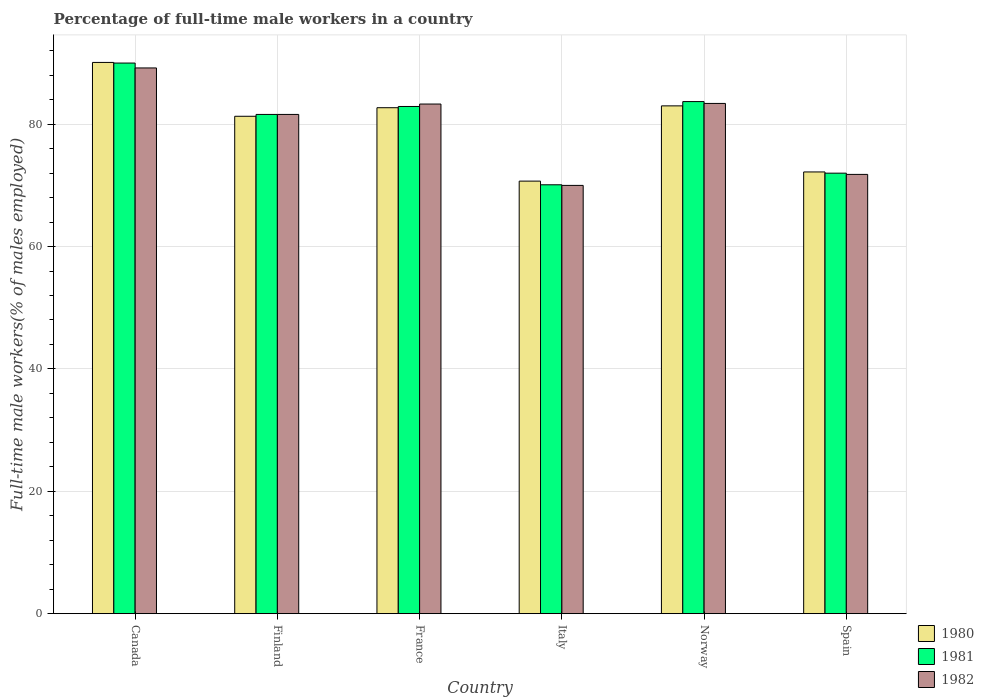How many different coloured bars are there?
Provide a short and direct response. 3. How many bars are there on the 5th tick from the left?
Offer a terse response. 3. What is the label of the 5th group of bars from the left?
Keep it short and to the point. Norway. In how many cases, is the number of bars for a given country not equal to the number of legend labels?
Provide a short and direct response. 0. What is the percentage of full-time male workers in 1981 in Norway?
Keep it short and to the point. 83.7. What is the total percentage of full-time male workers in 1980 in the graph?
Your answer should be very brief. 480. What is the difference between the percentage of full-time male workers in 1980 in Finland and that in Spain?
Offer a very short reply. 9.1. What is the average percentage of full-time male workers in 1982 per country?
Provide a short and direct response. 79.88. What is the difference between the percentage of full-time male workers of/in 1980 and percentage of full-time male workers of/in 1981 in Finland?
Your response must be concise. -0.3. What is the ratio of the percentage of full-time male workers in 1980 in France to that in Spain?
Your response must be concise. 1.15. Is the percentage of full-time male workers in 1980 in Canada less than that in Finland?
Provide a succinct answer. No. What is the difference between the highest and the second highest percentage of full-time male workers in 1981?
Offer a terse response. 6.3. What is the difference between the highest and the lowest percentage of full-time male workers in 1980?
Your response must be concise. 19.4. In how many countries, is the percentage of full-time male workers in 1980 greater than the average percentage of full-time male workers in 1980 taken over all countries?
Provide a succinct answer. 4. Is the sum of the percentage of full-time male workers in 1981 in France and Italy greater than the maximum percentage of full-time male workers in 1982 across all countries?
Offer a very short reply. Yes. What does the 2nd bar from the right in Canada represents?
Keep it short and to the point. 1981. How many bars are there?
Ensure brevity in your answer.  18. Does the graph contain any zero values?
Your answer should be very brief. No. Does the graph contain grids?
Make the answer very short. Yes. How are the legend labels stacked?
Your response must be concise. Vertical. What is the title of the graph?
Keep it short and to the point. Percentage of full-time male workers in a country. Does "1997" appear as one of the legend labels in the graph?
Offer a terse response. No. What is the label or title of the Y-axis?
Give a very brief answer. Full-time male workers(% of males employed). What is the Full-time male workers(% of males employed) of 1980 in Canada?
Your response must be concise. 90.1. What is the Full-time male workers(% of males employed) in 1981 in Canada?
Your response must be concise. 90. What is the Full-time male workers(% of males employed) in 1982 in Canada?
Ensure brevity in your answer.  89.2. What is the Full-time male workers(% of males employed) of 1980 in Finland?
Your response must be concise. 81.3. What is the Full-time male workers(% of males employed) of 1981 in Finland?
Keep it short and to the point. 81.6. What is the Full-time male workers(% of males employed) in 1982 in Finland?
Your answer should be very brief. 81.6. What is the Full-time male workers(% of males employed) of 1980 in France?
Give a very brief answer. 82.7. What is the Full-time male workers(% of males employed) of 1981 in France?
Your answer should be compact. 82.9. What is the Full-time male workers(% of males employed) in 1982 in France?
Keep it short and to the point. 83.3. What is the Full-time male workers(% of males employed) of 1980 in Italy?
Provide a succinct answer. 70.7. What is the Full-time male workers(% of males employed) in 1981 in Italy?
Make the answer very short. 70.1. What is the Full-time male workers(% of males employed) of 1982 in Italy?
Your answer should be very brief. 70. What is the Full-time male workers(% of males employed) of 1981 in Norway?
Your response must be concise. 83.7. What is the Full-time male workers(% of males employed) of 1982 in Norway?
Your answer should be compact. 83.4. What is the Full-time male workers(% of males employed) in 1980 in Spain?
Keep it short and to the point. 72.2. What is the Full-time male workers(% of males employed) in 1981 in Spain?
Offer a very short reply. 72. What is the Full-time male workers(% of males employed) in 1982 in Spain?
Offer a terse response. 71.8. Across all countries, what is the maximum Full-time male workers(% of males employed) in 1980?
Offer a very short reply. 90.1. Across all countries, what is the maximum Full-time male workers(% of males employed) of 1981?
Your response must be concise. 90. Across all countries, what is the maximum Full-time male workers(% of males employed) of 1982?
Your response must be concise. 89.2. Across all countries, what is the minimum Full-time male workers(% of males employed) of 1980?
Keep it short and to the point. 70.7. Across all countries, what is the minimum Full-time male workers(% of males employed) of 1981?
Offer a terse response. 70.1. Across all countries, what is the minimum Full-time male workers(% of males employed) in 1982?
Offer a terse response. 70. What is the total Full-time male workers(% of males employed) in 1980 in the graph?
Keep it short and to the point. 480. What is the total Full-time male workers(% of males employed) in 1981 in the graph?
Provide a succinct answer. 480.3. What is the total Full-time male workers(% of males employed) in 1982 in the graph?
Ensure brevity in your answer.  479.3. What is the difference between the Full-time male workers(% of males employed) of 1981 in Canada and that in Finland?
Provide a short and direct response. 8.4. What is the difference between the Full-time male workers(% of males employed) of 1980 in Canada and that in Italy?
Offer a very short reply. 19.4. What is the difference between the Full-time male workers(% of males employed) of 1981 in Canada and that in Norway?
Provide a short and direct response. 6.3. What is the difference between the Full-time male workers(% of males employed) of 1982 in Canada and that in Norway?
Provide a succinct answer. 5.8. What is the difference between the Full-time male workers(% of males employed) in 1980 in Canada and that in Spain?
Keep it short and to the point. 17.9. What is the difference between the Full-time male workers(% of males employed) of 1982 in Canada and that in Spain?
Provide a succinct answer. 17.4. What is the difference between the Full-time male workers(% of males employed) of 1980 in Finland and that in France?
Offer a terse response. -1.4. What is the difference between the Full-time male workers(% of males employed) in 1982 in Finland and that in France?
Make the answer very short. -1.7. What is the difference between the Full-time male workers(% of males employed) in 1982 in Finland and that in Italy?
Your answer should be compact. 11.6. What is the difference between the Full-time male workers(% of males employed) of 1982 in Finland and that in Norway?
Give a very brief answer. -1.8. What is the difference between the Full-time male workers(% of males employed) in 1981 in Finland and that in Spain?
Your response must be concise. 9.6. What is the difference between the Full-time male workers(% of males employed) of 1982 in Finland and that in Spain?
Offer a very short reply. 9.8. What is the difference between the Full-time male workers(% of males employed) in 1980 in France and that in Italy?
Give a very brief answer. 12. What is the difference between the Full-time male workers(% of males employed) in 1981 in France and that in Norway?
Make the answer very short. -0.8. What is the difference between the Full-time male workers(% of males employed) of 1980 in Italy and that in Norway?
Provide a short and direct response. -12.3. What is the difference between the Full-time male workers(% of males employed) in 1980 in Italy and that in Spain?
Offer a terse response. -1.5. What is the difference between the Full-time male workers(% of males employed) in 1982 in Italy and that in Spain?
Your answer should be very brief. -1.8. What is the difference between the Full-time male workers(% of males employed) of 1981 in Norway and that in Spain?
Provide a succinct answer. 11.7. What is the difference between the Full-time male workers(% of males employed) in 1982 in Norway and that in Spain?
Your answer should be very brief. 11.6. What is the difference between the Full-time male workers(% of males employed) of 1980 in Canada and the Full-time male workers(% of males employed) of 1982 in Finland?
Give a very brief answer. 8.5. What is the difference between the Full-time male workers(% of males employed) in 1981 in Canada and the Full-time male workers(% of males employed) in 1982 in Finland?
Ensure brevity in your answer.  8.4. What is the difference between the Full-time male workers(% of males employed) in 1980 in Canada and the Full-time male workers(% of males employed) in 1982 in France?
Your answer should be compact. 6.8. What is the difference between the Full-time male workers(% of males employed) in 1980 in Canada and the Full-time male workers(% of males employed) in 1982 in Italy?
Offer a terse response. 20.1. What is the difference between the Full-time male workers(% of males employed) in 1980 in Canada and the Full-time male workers(% of males employed) in 1981 in Spain?
Ensure brevity in your answer.  18.1. What is the difference between the Full-time male workers(% of males employed) in 1980 in Finland and the Full-time male workers(% of males employed) in 1982 in France?
Make the answer very short. -2. What is the difference between the Full-time male workers(% of males employed) of 1980 in Finland and the Full-time male workers(% of males employed) of 1981 in Italy?
Your answer should be very brief. 11.2. What is the difference between the Full-time male workers(% of males employed) in 1980 in Finland and the Full-time male workers(% of males employed) in 1981 in Norway?
Give a very brief answer. -2.4. What is the difference between the Full-time male workers(% of males employed) in 1980 in Finland and the Full-time male workers(% of males employed) in 1982 in Norway?
Your response must be concise. -2.1. What is the difference between the Full-time male workers(% of males employed) of 1981 in Finland and the Full-time male workers(% of males employed) of 1982 in Norway?
Provide a short and direct response. -1.8. What is the difference between the Full-time male workers(% of males employed) of 1980 in Finland and the Full-time male workers(% of males employed) of 1981 in Spain?
Give a very brief answer. 9.3. What is the difference between the Full-time male workers(% of males employed) in 1980 in Finland and the Full-time male workers(% of males employed) in 1982 in Spain?
Give a very brief answer. 9.5. What is the difference between the Full-time male workers(% of males employed) of 1981 in Finland and the Full-time male workers(% of males employed) of 1982 in Spain?
Your answer should be very brief. 9.8. What is the difference between the Full-time male workers(% of males employed) in 1980 in France and the Full-time male workers(% of males employed) in 1981 in Italy?
Your answer should be compact. 12.6. What is the difference between the Full-time male workers(% of males employed) in 1981 in France and the Full-time male workers(% of males employed) in 1982 in Italy?
Provide a succinct answer. 12.9. What is the difference between the Full-time male workers(% of males employed) in 1981 in France and the Full-time male workers(% of males employed) in 1982 in Norway?
Provide a short and direct response. -0.5. What is the difference between the Full-time male workers(% of males employed) in 1980 in France and the Full-time male workers(% of males employed) in 1981 in Spain?
Keep it short and to the point. 10.7. What is the difference between the Full-time male workers(% of males employed) in 1980 in France and the Full-time male workers(% of males employed) in 1982 in Spain?
Your answer should be compact. 10.9. What is the difference between the Full-time male workers(% of males employed) in 1981 in France and the Full-time male workers(% of males employed) in 1982 in Spain?
Make the answer very short. 11.1. What is the difference between the Full-time male workers(% of males employed) in 1980 in Italy and the Full-time male workers(% of males employed) in 1982 in Norway?
Give a very brief answer. -12.7. What is the difference between the Full-time male workers(% of males employed) of 1980 in Italy and the Full-time male workers(% of males employed) of 1982 in Spain?
Give a very brief answer. -1.1. What is the difference between the Full-time male workers(% of males employed) in 1980 in Norway and the Full-time male workers(% of males employed) in 1982 in Spain?
Offer a very short reply. 11.2. What is the average Full-time male workers(% of males employed) in 1980 per country?
Ensure brevity in your answer.  80. What is the average Full-time male workers(% of males employed) in 1981 per country?
Offer a very short reply. 80.05. What is the average Full-time male workers(% of males employed) in 1982 per country?
Keep it short and to the point. 79.88. What is the difference between the Full-time male workers(% of males employed) in 1980 and Full-time male workers(% of males employed) in 1981 in Canada?
Give a very brief answer. 0.1. What is the difference between the Full-time male workers(% of males employed) of 1980 and Full-time male workers(% of males employed) of 1982 in Canada?
Offer a very short reply. 0.9. What is the difference between the Full-time male workers(% of males employed) in 1980 and Full-time male workers(% of males employed) in 1981 in Finland?
Provide a short and direct response. -0.3. What is the difference between the Full-time male workers(% of males employed) in 1980 and Full-time male workers(% of males employed) in 1982 in Finland?
Offer a terse response. -0.3. What is the difference between the Full-time male workers(% of males employed) in 1981 and Full-time male workers(% of males employed) in 1982 in France?
Keep it short and to the point. -0.4. What is the difference between the Full-time male workers(% of males employed) of 1980 and Full-time male workers(% of males employed) of 1982 in Italy?
Your response must be concise. 0.7. What is the difference between the Full-time male workers(% of males employed) in 1981 and Full-time male workers(% of males employed) in 1982 in Italy?
Provide a short and direct response. 0.1. What is the difference between the Full-time male workers(% of males employed) in 1980 and Full-time male workers(% of males employed) in 1981 in Norway?
Provide a short and direct response. -0.7. What is the ratio of the Full-time male workers(% of males employed) of 1980 in Canada to that in Finland?
Keep it short and to the point. 1.11. What is the ratio of the Full-time male workers(% of males employed) of 1981 in Canada to that in Finland?
Ensure brevity in your answer.  1.1. What is the ratio of the Full-time male workers(% of males employed) in 1982 in Canada to that in Finland?
Ensure brevity in your answer.  1.09. What is the ratio of the Full-time male workers(% of males employed) of 1980 in Canada to that in France?
Give a very brief answer. 1.09. What is the ratio of the Full-time male workers(% of males employed) in 1981 in Canada to that in France?
Keep it short and to the point. 1.09. What is the ratio of the Full-time male workers(% of males employed) of 1982 in Canada to that in France?
Keep it short and to the point. 1.07. What is the ratio of the Full-time male workers(% of males employed) of 1980 in Canada to that in Italy?
Ensure brevity in your answer.  1.27. What is the ratio of the Full-time male workers(% of males employed) of 1981 in Canada to that in Italy?
Make the answer very short. 1.28. What is the ratio of the Full-time male workers(% of males employed) of 1982 in Canada to that in Italy?
Your response must be concise. 1.27. What is the ratio of the Full-time male workers(% of males employed) of 1980 in Canada to that in Norway?
Make the answer very short. 1.09. What is the ratio of the Full-time male workers(% of males employed) of 1981 in Canada to that in Norway?
Keep it short and to the point. 1.08. What is the ratio of the Full-time male workers(% of males employed) in 1982 in Canada to that in Norway?
Your answer should be compact. 1.07. What is the ratio of the Full-time male workers(% of males employed) of 1980 in Canada to that in Spain?
Provide a short and direct response. 1.25. What is the ratio of the Full-time male workers(% of males employed) of 1982 in Canada to that in Spain?
Ensure brevity in your answer.  1.24. What is the ratio of the Full-time male workers(% of males employed) of 1980 in Finland to that in France?
Provide a succinct answer. 0.98. What is the ratio of the Full-time male workers(% of males employed) of 1981 in Finland to that in France?
Your response must be concise. 0.98. What is the ratio of the Full-time male workers(% of males employed) in 1982 in Finland to that in France?
Keep it short and to the point. 0.98. What is the ratio of the Full-time male workers(% of males employed) of 1980 in Finland to that in Italy?
Make the answer very short. 1.15. What is the ratio of the Full-time male workers(% of males employed) of 1981 in Finland to that in Italy?
Make the answer very short. 1.16. What is the ratio of the Full-time male workers(% of males employed) in 1982 in Finland to that in Italy?
Give a very brief answer. 1.17. What is the ratio of the Full-time male workers(% of males employed) of 1980 in Finland to that in Norway?
Your answer should be compact. 0.98. What is the ratio of the Full-time male workers(% of males employed) of 1981 in Finland to that in Norway?
Provide a succinct answer. 0.97. What is the ratio of the Full-time male workers(% of males employed) in 1982 in Finland to that in Norway?
Your response must be concise. 0.98. What is the ratio of the Full-time male workers(% of males employed) of 1980 in Finland to that in Spain?
Offer a very short reply. 1.13. What is the ratio of the Full-time male workers(% of males employed) in 1981 in Finland to that in Spain?
Your response must be concise. 1.13. What is the ratio of the Full-time male workers(% of males employed) in 1982 in Finland to that in Spain?
Give a very brief answer. 1.14. What is the ratio of the Full-time male workers(% of males employed) of 1980 in France to that in Italy?
Make the answer very short. 1.17. What is the ratio of the Full-time male workers(% of males employed) of 1981 in France to that in Italy?
Keep it short and to the point. 1.18. What is the ratio of the Full-time male workers(% of males employed) in 1982 in France to that in Italy?
Keep it short and to the point. 1.19. What is the ratio of the Full-time male workers(% of males employed) in 1980 in France to that in Spain?
Ensure brevity in your answer.  1.15. What is the ratio of the Full-time male workers(% of males employed) in 1981 in France to that in Spain?
Your answer should be compact. 1.15. What is the ratio of the Full-time male workers(% of males employed) in 1982 in France to that in Spain?
Offer a very short reply. 1.16. What is the ratio of the Full-time male workers(% of males employed) of 1980 in Italy to that in Norway?
Keep it short and to the point. 0.85. What is the ratio of the Full-time male workers(% of males employed) in 1981 in Italy to that in Norway?
Provide a short and direct response. 0.84. What is the ratio of the Full-time male workers(% of males employed) of 1982 in Italy to that in Norway?
Give a very brief answer. 0.84. What is the ratio of the Full-time male workers(% of males employed) in 1980 in Italy to that in Spain?
Keep it short and to the point. 0.98. What is the ratio of the Full-time male workers(% of males employed) of 1981 in Italy to that in Spain?
Provide a succinct answer. 0.97. What is the ratio of the Full-time male workers(% of males employed) in 1982 in Italy to that in Spain?
Your answer should be very brief. 0.97. What is the ratio of the Full-time male workers(% of males employed) in 1980 in Norway to that in Spain?
Ensure brevity in your answer.  1.15. What is the ratio of the Full-time male workers(% of males employed) in 1981 in Norway to that in Spain?
Your answer should be very brief. 1.16. What is the ratio of the Full-time male workers(% of males employed) of 1982 in Norway to that in Spain?
Give a very brief answer. 1.16. What is the difference between the highest and the second highest Full-time male workers(% of males employed) of 1982?
Keep it short and to the point. 5.8. What is the difference between the highest and the lowest Full-time male workers(% of males employed) of 1980?
Make the answer very short. 19.4. 